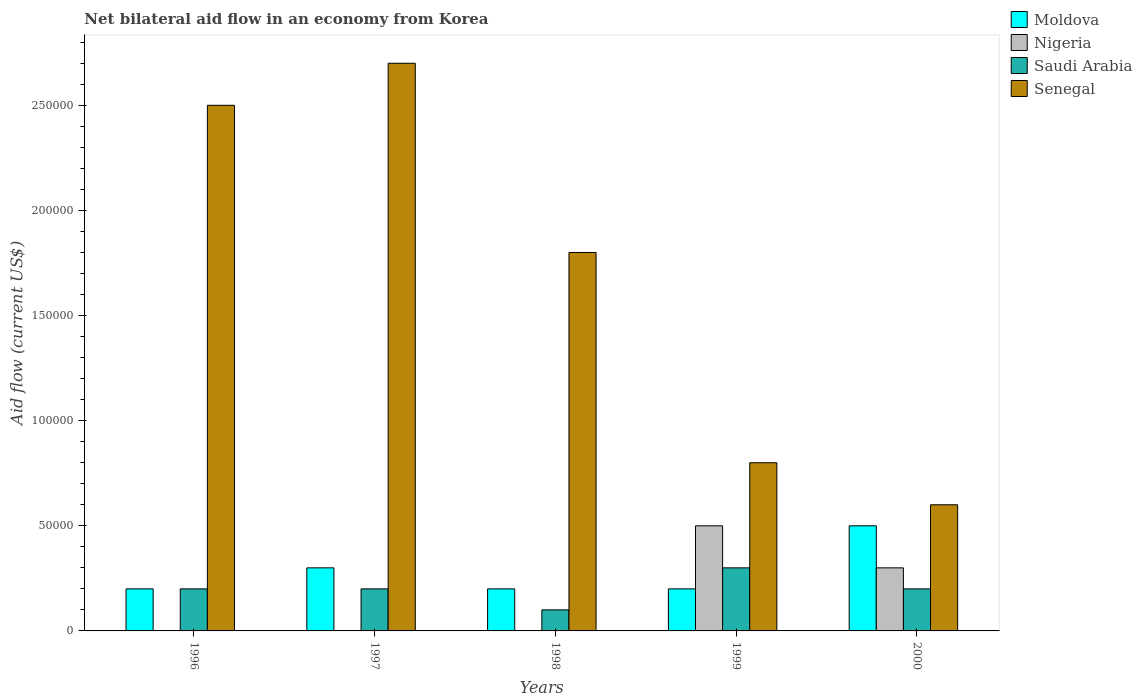Are the number of bars per tick equal to the number of legend labels?
Give a very brief answer. No. Are the number of bars on each tick of the X-axis equal?
Your answer should be very brief. No. How many bars are there on the 5th tick from the left?
Your response must be concise. 4. How many bars are there on the 1st tick from the right?
Your answer should be compact. 4. What is the label of the 2nd group of bars from the left?
Make the answer very short. 1997. What is the net bilateral aid flow in Moldova in 1997?
Your answer should be compact. 3.00e+04. Across all years, what is the minimum net bilateral aid flow in Senegal?
Keep it short and to the point. 6.00e+04. What is the total net bilateral aid flow in Moldova in the graph?
Make the answer very short. 1.40e+05. What is the difference between the net bilateral aid flow in Saudi Arabia in 1997 and that in 2000?
Your response must be concise. 0. What is the difference between the net bilateral aid flow in Moldova in 1998 and the net bilateral aid flow in Saudi Arabia in 1996?
Give a very brief answer. 0. What is the average net bilateral aid flow in Saudi Arabia per year?
Offer a terse response. 2.00e+04. What is the ratio of the net bilateral aid flow in Saudi Arabia in 1998 to that in 2000?
Give a very brief answer. 0.5. Is the net bilateral aid flow in Moldova in 1997 less than that in 1999?
Your answer should be compact. No. What is the difference between the highest and the second highest net bilateral aid flow in Senegal?
Ensure brevity in your answer.  2.00e+04. In how many years, is the net bilateral aid flow in Saudi Arabia greater than the average net bilateral aid flow in Saudi Arabia taken over all years?
Keep it short and to the point. 1. Is the sum of the net bilateral aid flow in Moldova in 1997 and 1998 greater than the maximum net bilateral aid flow in Nigeria across all years?
Offer a very short reply. No. Is it the case that in every year, the sum of the net bilateral aid flow in Nigeria and net bilateral aid flow in Saudi Arabia is greater than the sum of net bilateral aid flow in Moldova and net bilateral aid flow in Senegal?
Provide a succinct answer. No. Are all the bars in the graph horizontal?
Offer a terse response. No. What is the difference between two consecutive major ticks on the Y-axis?
Provide a succinct answer. 5.00e+04. How many legend labels are there?
Offer a very short reply. 4. What is the title of the graph?
Make the answer very short. Net bilateral aid flow in an economy from Korea. What is the label or title of the X-axis?
Your answer should be very brief. Years. What is the Aid flow (current US$) of Moldova in 1996?
Ensure brevity in your answer.  2.00e+04. What is the Aid flow (current US$) in Saudi Arabia in 1996?
Your answer should be compact. 2.00e+04. What is the Aid flow (current US$) of Moldova in 1997?
Give a very brief answer. 3.00e+04. What is the Aid flow (current US$) of Saudi Arabia in 1997?
Provide a succinct answer. 2.00e+04. What is the Aid flow (current US$) in Moldova in 1998?
Give a very brief answer. 2.00e+04. What is the Aid flow (current US$) of Saudi Arabia in 1998?
Your answer should be very brief. 10000. What is the Aid flow (current US$) of Nigeria in 1999?
Ensure brevity in your answer.  5.00e+04. What is the Aid flow (current US$) in Saudi Arabia in 1999?
Your answer should be compact. 3.00e+04. What is the Aid flow (current US$) in Moldova in 2000?
Make the answer very short. 5.00e+04. What is the Aid flow (current US$) in Nigeria in 2000?
Make the answer very short. 3.00e+04. What is the Aid flow (current US$) of Saudi Arabia in 2000?
Your answer should be compact. 2.00e+04. What is the Aid flow (current US$) in Senegal in 2000?
Your response must be concise. 6.00e+04. Across all years, what is the maximum Aid flow (current US$) in Senegal?
Your answer should be very brief. 2.70e+05. Across all years, what is the minimum Aid flow (current US$) of Nigeria?
Provide a short and direct response. 0. Across all years, what is the minimum Aid flow (current US$) of Saudi Arabia?
Offer a terse response. 10000. Across all years, what is the minimum Aid flow (current US$) of Senegal?
Your answer should be very brief. 6.00e+04. What is the total Aid flow (current US$) of Moldova in the graph?
Provide a short and direct response. 1.40e+05. What is the total Aid flow (current US$) in Saudi Arabia in the graph?
Ensure brevity in your answer.  1.00e+05. What is the total Aid flow (current US$) of Senegal in the graph?
Your response must be concise. 8.40e+05. What is the difference between the Aid flow (current US$) in Senegal in 1996 and that in 1997?
Keep it short and to the point. -2.00e+04. What is the difference between the Aid flow (current US$) of Moldova in 1996 and that in 1998?
Provide a short and direct response. 0. What is the difference between the Aid flow (current US$) in Saudi Arabia in 1996 and that in 1998?
Your answer should be very brief. 10000. What is the difference between the Aid flow (current US$) in Senegal in 1996 and that in 1998?
Your answer should be compact. 7.00e+04. What is the difference between the Aid flow (current US$) of Moldova in 1996 and that in 2000?
Ensure brevity in your answer.  -3.00e+04. What is the difference between the Aid flow (current US$) of Senegal in 1996 and that in 2000?
Give a very brief answer. 1.90e+05. What is the difference between the Aid flow (current US$) in Moldova in 1997 and that in 1998?
Your answer should be compact. 10000. What is the difference between the Aid flow (current US$) of Saudi Arabia in 1997 and that in 1998?
Your answer should be very brief. 10000. What is the difference between the Aid flow (current US$) in Moldova in 1997 and that in 1999?
Your answer should be very brief. 10000. What is the difference between the Aid flow (current US$) of Saudi Arabia in 1997 and that in 1999?
Your response must be concise. -10000. What is the difference between the Aid flow (current US$) in Moldova in 1997 and that in 2000?
Your response must be concise. -2.00e+04. What is the difference between the Aid flow (current US$) of Saudi Arabia in 1998 and that in 1999?
Ensure brevity in your answer.  -2.00e+04. What is the difference between the Aid flow (current US$) in Senegal in 1998 and that in 1999?
Offer a very short reply. 1.00e+05. What is the difference between the Aid flow (current US$) of Saudi Arabia in 1998 and that in 2000?
Provide a succinct answer. -10000. What is the difference between the Aid flow (current US$) of Senegal in 1998 and that in 2000?
Offer a terse response. 1.20e+05. What is the difference between the Aid flow (current US$) in Moldova in 1996 and the Aid flow (current US$) in Saudi Arabia in 1997?
Your answer should be compact. 0. What is the difference between the Aid flow (current US$) in Saudi Arabia in 1996 and the Aid flow (current US$) in Senegal in 1997?
Provide a succinct answer. -2.50e+05. What is the difference between the Aid flow (current US$) of Moldova in 1996 and the Aid flow (current US$) of Saudi Arabia in 1998?
Ensure brevity in your answer.  10000. What is the difference between the Aid flow (current US$) of Moldova in 1996 and the Aid flow (current US$) of Senegal in 1998?
Your answer should be compact. -1.60e+05. What is the difference between the Aid flow (current US$) in Saudi Arabia in 1996 and the Aid flow (current US$) in Senegal in 1998?
Offer a terse response. -1.60e+05. What is the difference between the Aid flow (current US$) of Moldova in 1996 and the Aid flow (current US$) of Senegal in 1999?
Give a very brief answer. -6.00e+04. What is the difference between the Aid flow (current US$) in Moldova in 1996 and the Aid flow (current US$) in Nigeria in 2000?
Keep it short and to the point. -10000. What is the difference between the Aid flow (current US$) in Saudi Arabia in 1996 and the Aid flow (current US$) in Senegal in 2000?
Offer a very short reply. -4.00e+04. What is the difference between the Aid flow (current US$) of Moldova in 1997 and the Aid flow (current US$) of Saudi Arabia in 1998?
Make the answer very short. 2.00e+04. What is the difference between the Aid flow (current US$) in Moldova in 1997 and the Aid flow (current US$) in Saudi Arabia in 1999?
Provide a short and direct response. 0. What is the difference between the Aid flow (current US$) in Moldova in 1997 and the Aid flow (current US$) in Senegal in 1999?
Provide a succinct answer. -5.00e+04. What is the difference between the Aid flow (current US$) in Moldova in 1997 and the Aid flow (current US$) in Nigeria in 2000?
Ensure brevity in your answer.  0. What is the difference between the Aid flow (current US$) in Saudi Arabia in 1997 and the Aid flow (current US$) in Senegal in 2000?
Give a very brief answer. -4.00e+04. What is the difference between the Aid flow (current US$) in Moldova in 1998 and the Aid flow (current US$) in Nigeria in 1999?
Ensure brevity in your answer.  -3.00e+04. What is the difference between the Aid flow (current US$) of Moldova in 1998 and the Aid flow (current US$) of Saudi Arabia in 1999?
Provide a short and direct response. -10000. What is the difference between the Aid flow (current US$) of Moldova in 1998 and the Aid flow (current US$) of Senegal in 1999?
Your answer should be compact. -6.00e+04. What is the difference between the Aid flow (current US$) in Saudi Arabia in 1998 and the Aid flow (current US$) in Senegal in 1999?
Make the answer very short. -7.00e+04. What is the difference between the Aid flow (current US$) in Moldova in 1998 and the Aid flow (current US$) in Saudi Arabia in 2000?
Provide a succinct answer. 0. What is the difference between the Aid flow (current US$) in Saudi Arabia in 1998 and the Aid flow (current US$) in Senegal in 2000?
Ensure brevity in your answer.  -5.00e+04. What is the difference between the Aid flow (current US$) of Moldova in 1999 and the Aid flow (current US$) of Senegal in 2000?
Give a very brief answer. -4.00e+04. What is the average Aid flow (current US$) in Moldova per year?
Your response must be concise. 2.80e+04. What is the average Aid flow (current US$) of Nigeria per year?
Your answer should be very brief. 1.60e+04. What is the average Aid flow (current US$) in Senegal per year?
Provide a succinct answer. 1.68e+05. In the year 1996, what is the difference between the Aid flow (current US$) of Saudi Arabia and Aid flow (current US$) of Senegal?
Your answer should be compact. -2.30e+05. In the year 1997, what is the difference between the Aid flow (current US$) of Moldova and Aid flow (current US$) of Senegal?
Keep it short and to the point. -2.40e+05. In the year 1997, what is the difference between the Aid flow (current US$) in Saudi Arabia and Aid flow (current US$) in Senegal?
Ensure brevity in your answer.  -2.50e+05. In the year 1999, what is the difference between the Aid flow (current US$) of Moldova and Aid flow (current US$) of Saudi Arabia?
Your answer should be very brief. -10000. In the year 1999, what is the difference between the Aid flow (current US$) in Nigeria and Aid flow (current US$) in Senegal?
Provide a short and direct response. -3.00e+04. In the year 2000, what is the difference between the Aid flow (current US$) in Moldova and Aid flow (current US$) in Saudi Arabia?
Provide a short and direct response. 3.00e+04. In the year 2000, what is the difference between the Aid flow (current US$) of Nigeria and Aid flow (current US$) of Senegal?
Offer a terse response. -3.00e+04. What is the ratio of the Aid flow (current US$) of Senegal in 1996 to that in 1997?
Ensure brevity in your answer.  0.93. What is the ratio of the Aid flow (current US$) of Moldova in 1996 to that in 1998?
Give a very brief answer. 1. What is the ratio of the Aid flow (current US$) in Saudi Arabia in 1996 to that in 1998?
Offer a terse response. 2. What is the ratio of the Aid flow (current US$) of Senegal in 1996 to that in 1998?
Ensure brevity in your answer.  1.39. What is the ratio of the Aid flow (current US$) of Senegal in 1996 to that in 1999?
Make the answer very short. 3.12. What is the ratio of the Aid flow (current US$) of Moldova in 1996 to that in 2000?
Your response must be concise. 0.4. What is the ratio of the Aid flow (current US$) in Saudi Arabia in 1996 to that in 2000?
Ensure brevity in your answer.  1. What is the ratio of the Aid flow (current US$) in Senegal in 1996 to that in 2000?
Provide a short and direct response. 4.17. What is the ratio of the Aid flow (current US$) in Saudi Arabia in 1997 to that in 1998?
Your answer should be compact. 2. What is the ratio of the Aid flow (current US$) in Senegal in 1997 to that in 1998?
Offer a terse response. 1.5. What is the ratio of the Aid flow (current US$) in Moldova in 1997 to that in 1999?
Offer a terse response. 1.5. What is the ratio of the Aid flow (current US$) in Saudi Arabia in 1997 to that in 1999?
Offer a terse response. 0.67. What is the ratio of the Aid flow (current US$) in Senegal in 1997 to that in 1999?
Offer a very short reply. 3.38. What is the ratio of the Aid flow (current US$) in Moldova in 1997 to that in 2000?
Your answer should be very brief. 0.6. What is the ratio of the Aid flow (current US$) in Senegal in 1997 to that in 2000?
Your answer should be compact. 4.5. What is the ratio of the Aid flow (current US$) of Senegal in 1998 to that in 1999?
Provide a short and direct response. 2.25. What is the ratio of the Aid flow (current US$) in Moldova in 1998 to that in 2000?
Keep it short and to the point. 0.4. What is the ratio of the Aid flow (current US$) in Nigeria in 1999 to that in 2000?
Offer a very short reply. 1.67. What is the ratio of the Aid flow (current US$) in Saudi Arabia in 1999 to that in 2000?
Make the answer very short. 1.5. What is the difference between the highest and the second highest Aid flow (current US$) of Senegal?
Your answer should be very brief. 2.00e+04. What is the difference between the highest and the lowest Aid flow (current US$) of Saudi Arabia?
Offer a terse response. 2.00e+04. What is the difference between the highest and the lowest Aid flow (current US$) of Senegal?
Your answer should be compact. 2.10e+05. 